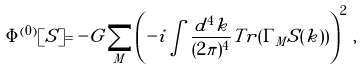<formula> <loc_0><loc_0><loc_500><loc_500>\Phi ^ { ( 0 ) } [ S ] = - G \sum _ { M } \left ( - i \int \frac { d ^ { 4 } k } { ( 2 \pi ) ^ { 4 } } T r ( \Gamma _ { M } S ( k ) ) \right ) ^ { 2 } \, ,</formula> 